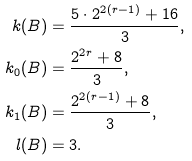Convert formula to latex. <formula><loc_0><loc_0><loc_500><loc_500>k ( B ) & = \frac { 5 \cdot 2 ^ { 2 ( r - 1 ) } + 1 6 } { 3 } , \\ k _ { 0 } ( B ) & = \frac { 2 ^ { 2 r } + 8 } { 3 } , \\ k _ { 1 } ( B ) & = \frac { 2 ^ { 2 ( r - 1 ) } + 8 } { 3 } , \\ l ( B ) & = 3 .</formula> 